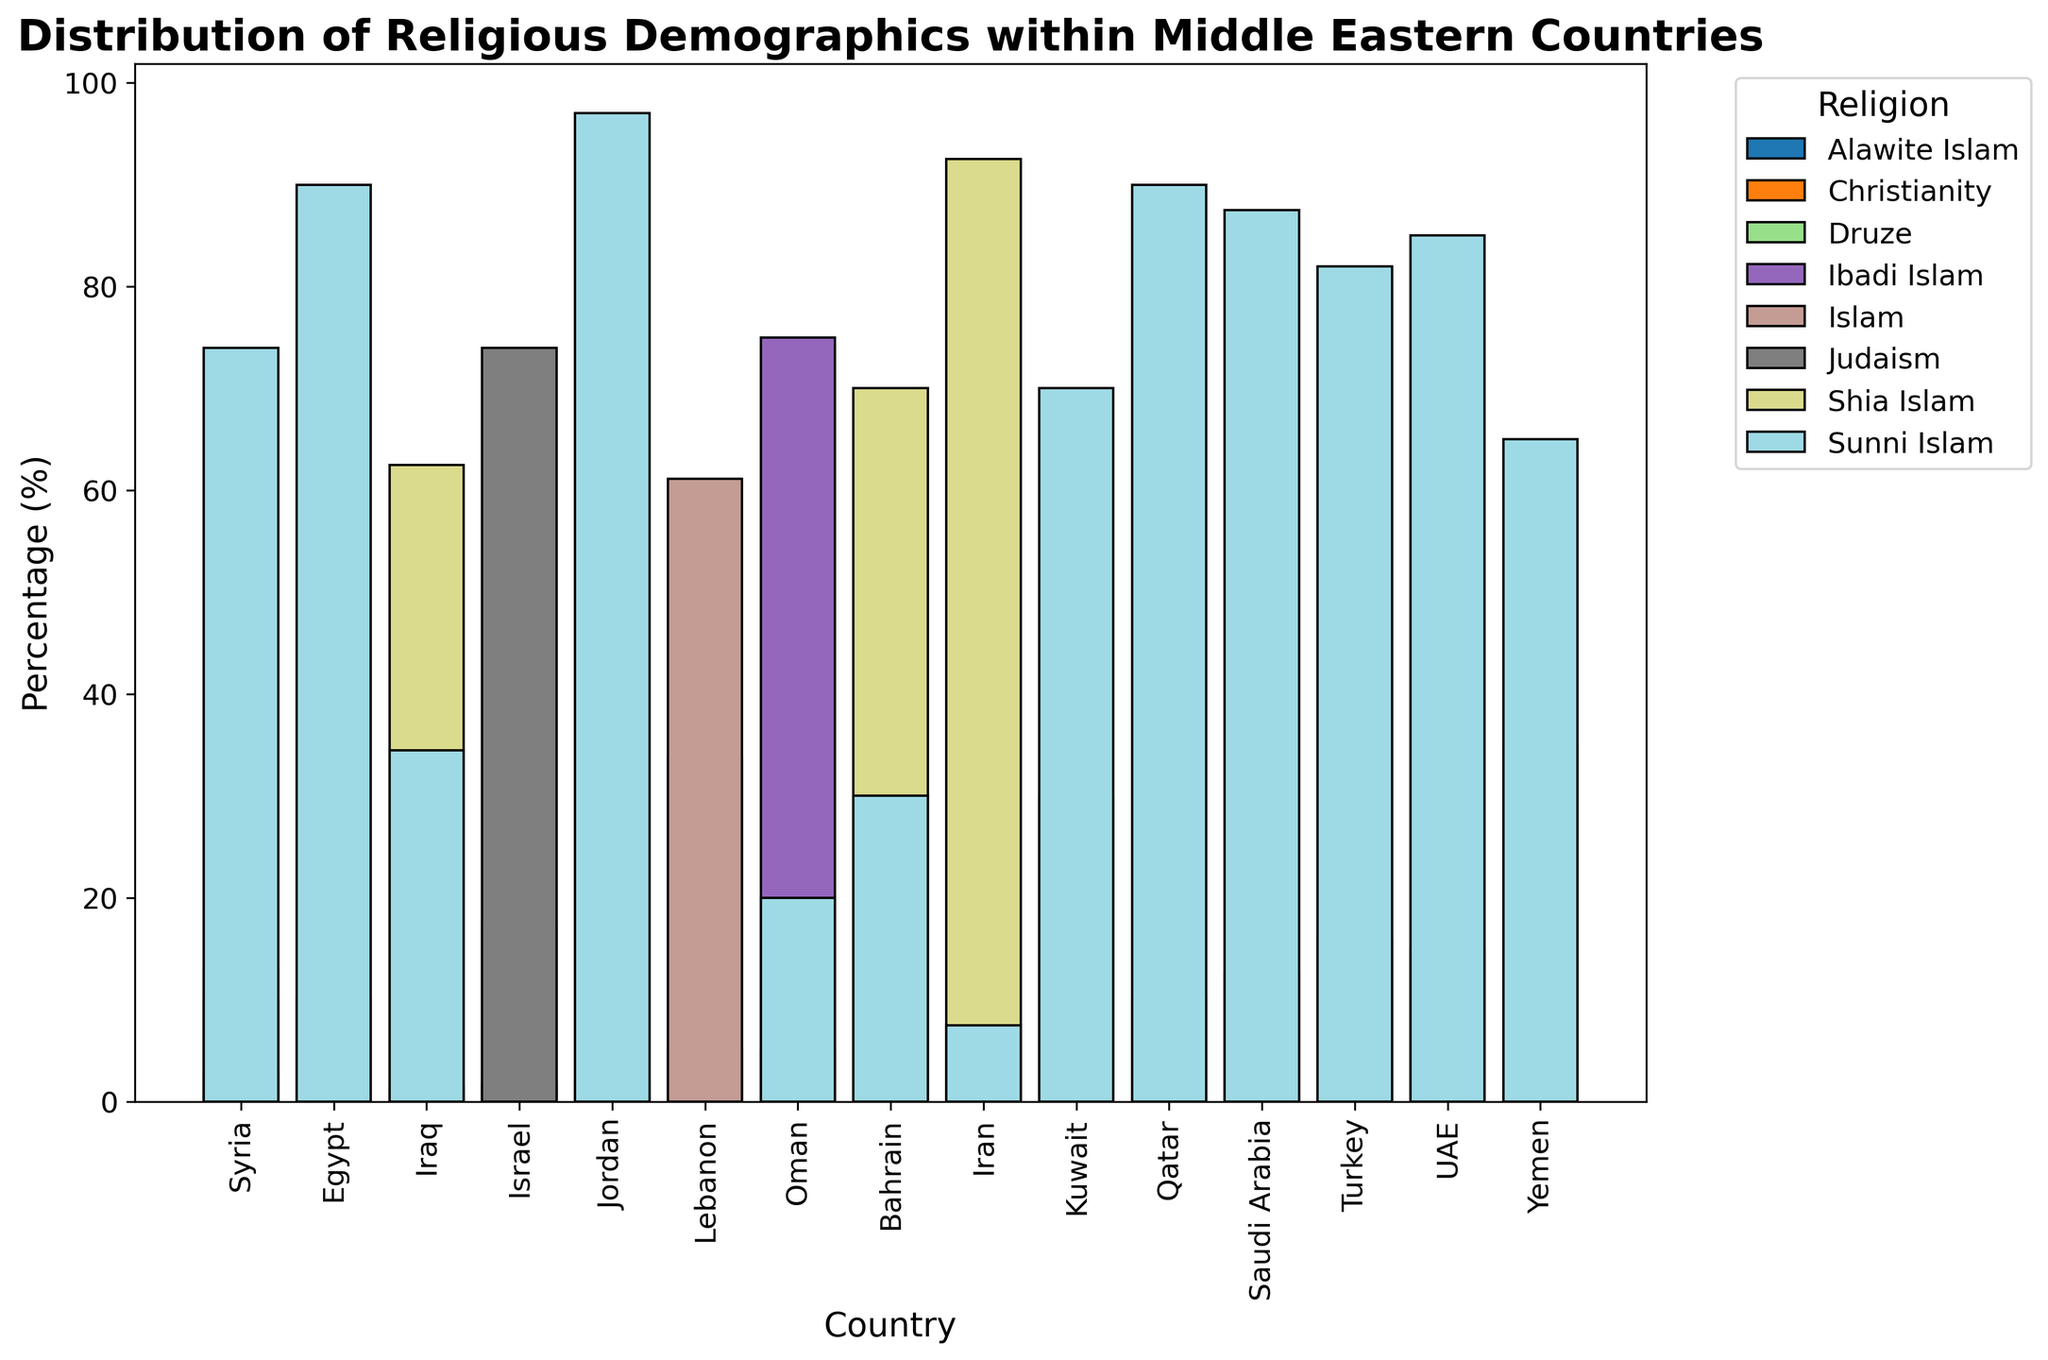Which country has the highest percentage of Shia Islam? Looking at the bars labeled "Shia Islam," the tallest bar corresponds to Iran, which reaches up to 92.5%.
Answer: Iran Among countries in the dataset, which religion predominantly exists in Saudi Arabia? Examining the bars for Saudi Arabia, the "Sunni Islam" bar is much taller compared to "Shia Islam," falling in the range of 87.5%.
Answer: Sunni Islam Compare the percentage of Christianity in Egypt and Israel. Which country has a higher percentage? For Egypt, the bar for Christianity shows 10%. For Israel, the corresponding bar shows 2%. Therefore, Egypt has a higher percentage of Christianity.
Answer: Egypt What is the combined percentage of Sunni and Shia Islam in Bahrain? Bahrain's Sunni Islam is at 30% and Shia Islam is at 70%. Summing these gives 30 + 70 = 100%.
Answer: 100% Which religion has the fewest adherents in Lebanon? In Lebanon, Christianity has about 33.7%, Islam 61.1%, and Druze 5.2%. The smallest percentage is for Druze at 5.2%.
Answer: Druze In which countries is Druze practiced and how do their percentages compare? Druze is practiced in Israel and Syria. Israel shows 1.6% while Syria shows 3%. Comparing these two, Syria has a higher percentage of Druze followers.
Answer: Israel (1.6%) and Syria (3%) What is the average percentage of Shia Muslims in all countries listed? Sum all the Shia Islam percentages: 70 (Bahrain) + (90+95)/2 (Iran) + (60+65)/2 (Iraq) + 30 (Kuwait) + 5 (Oman) + (10+15)/2 (Saudi Arabia) + 16 (Turkey) + 15 (UAE) + 35 (Yemen) = 407.5. Divide by the number of data points = 407.5/9 ≈ 45.28%
Answer: ~45.28% Compare the religious demographics of Syria and Jordan. Which country has more religious diversity? Syria has Sunni Islam (74%), Alawite Islam (13%), Christianity (10%), and Druze (3%) totaling 4 religions. Jordan has Sunni Islam (97%) and Christianity (2%) totaling 2 religions. Syria thus has more religious diversity.
Answer: Syria In which country does Judaism have the largest representation and what is the percentage? Looking at the bars for Judaism, Israel stands out with a percentage of 74%. Other countries do not show any percentage for Judaism.
Answer: Israel (74%) Which three countries have the highest percentage of Christianity, and what are those percentages? Identify and order the bars for Christianity: Egypt (10%), Lebanon (33.7%), Syria (10%). Lebanon has the highest, followed by Egypt and Syria both at 10%.
Answer: Lebanon (33.7%), Egypt (10%), Syria (10%) 